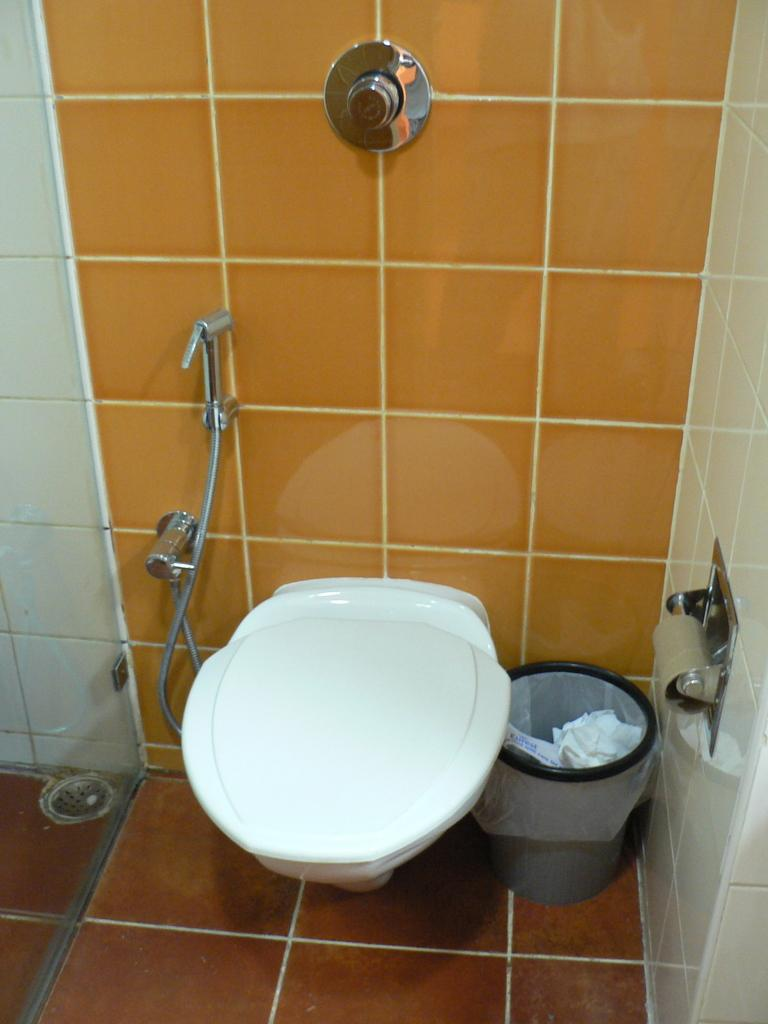What type of room is depicted in the image? The image is of a washroom's interior. What feature is present for flushing the toilet? There is a flush button in the washroom. What is used to enclose the space in the washroom? The washroom has walls. What is provided for disposing of waste in the washroom? There is a bin in the washroom. What is available for drying hands in the washroom? A tissue holder is present in the washroom. What is the main fixture for waste elimination in the washroom? There is a toilet seat in the washroom. What is an additional feature for cleaning in the washroom? A hand shower is visible in the washroom. What type of reward can be seen hanging from the ceiling in the image? There is no reward visible in the image; it is a washroom with various fixtures and features. 